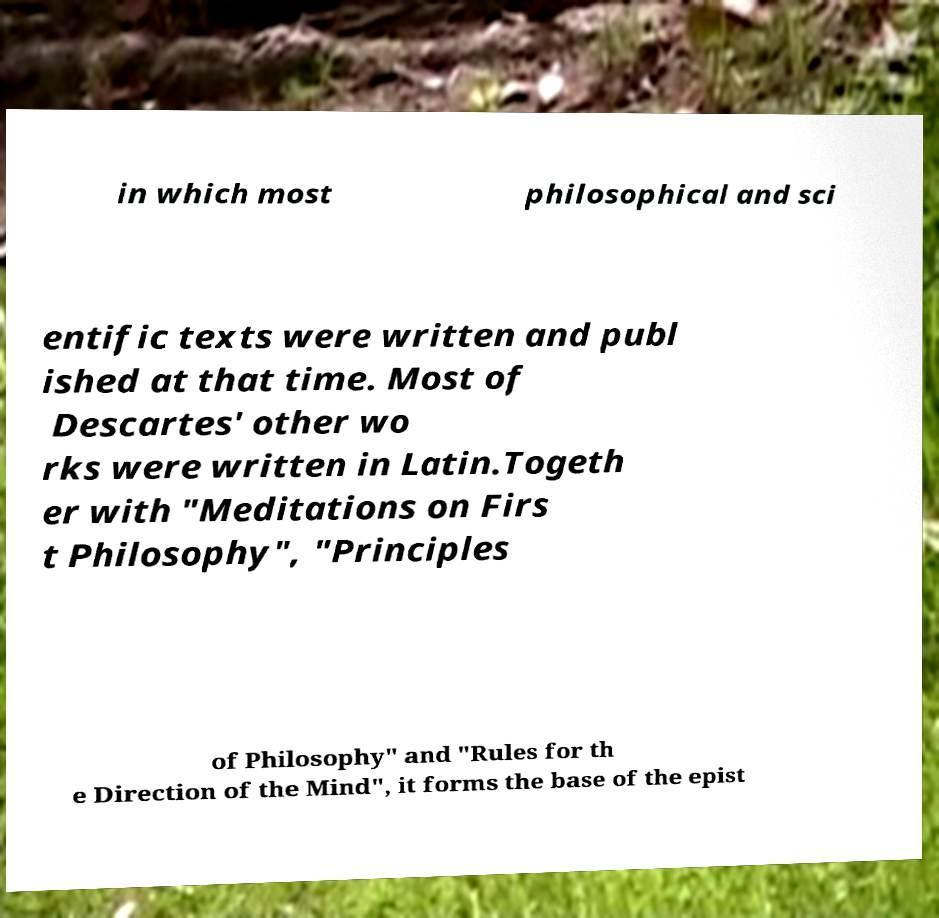What messages or text are displayed in this image? I need them in a readable, typed format. in which most philosophical and sci entific texts were written and publ ished at that time. Most of Descartes' other wo rks were written in Latin.Togeth er with "Meditations on Firs t Philosophy", "Principles of Philosophy" and "Rules for th e Direction of the Mind", it forms the base of the epist 